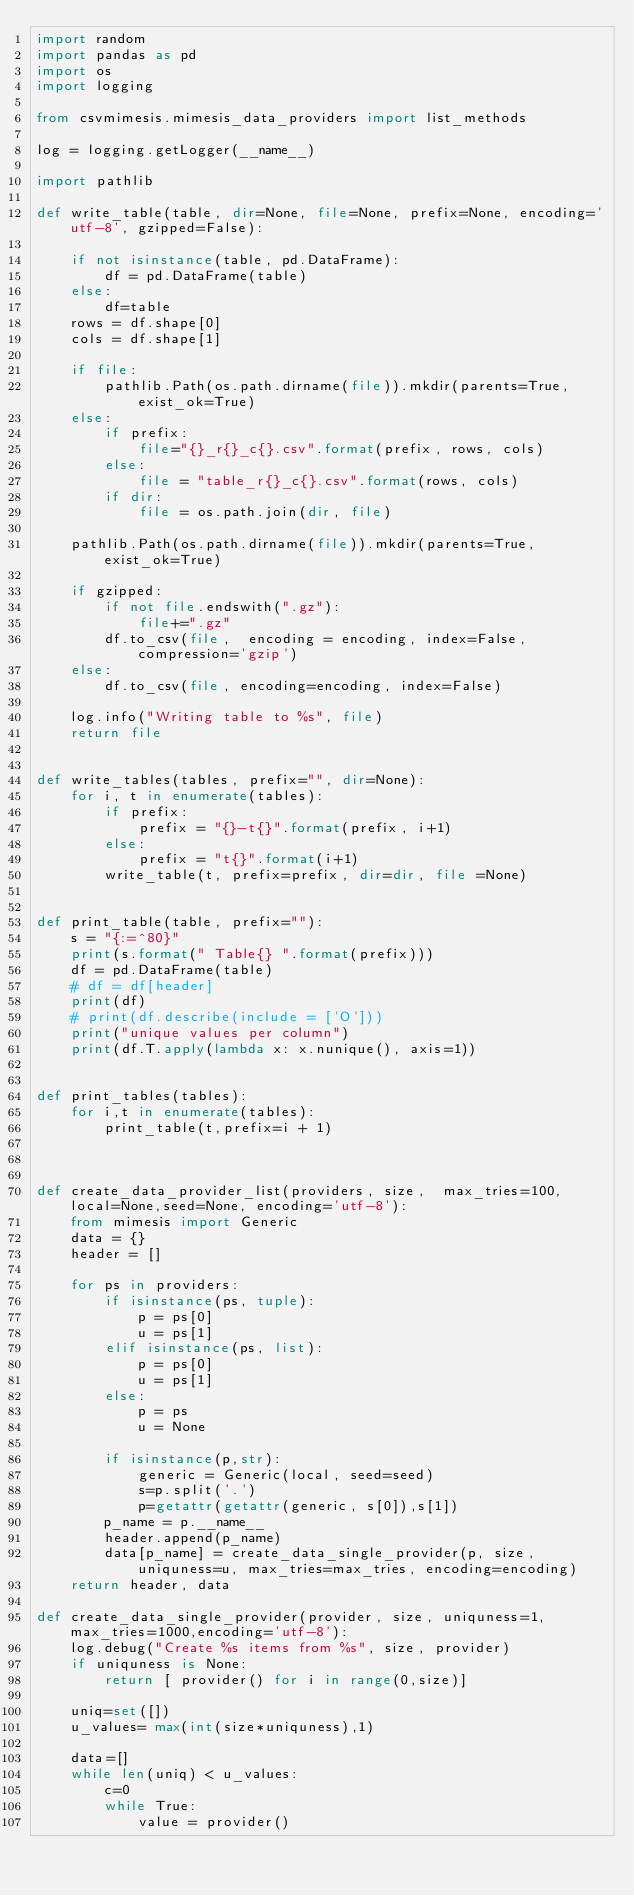Convert code to text. <code><loc_0><loc_0><loc_500><loc_500><_Python_>import random
import pandas as pd
import os
import logging

from csvmimesis.mimesis_data_providers import list_methods

log = logging.getLogger(__name__)

import pathlib

def write_table(table, dir=None, file=None, prefix=None, encoding='utf-8', gzipped=False):

    if not isinstance(table, pd.DataFrame):
        df = pd.DataFrame(table)
    else:
        df=table
    rows = df.shape[0]
    cols = df.shape[1]

    if file:
        pathlib.Path(os.path.dirname(file)).mkdir(parents=True, exist_ok=True)
    else:
        if prefix:
            file="{}_r{}_c{}.csv".format(prefix, rows, cols)
        else:
            file = "table_r{}_c{}.csv".format(rows, cols)
        if dir:
            file = os.path.join(dir, file)

    pathlib.Path(os.path.dirname(file)).mkdir(parents=True, exist_ok=True)

    if gzipped:
        if not file.endswith(".gz"):
            file+=".gz"
        df.to_csv(file,  encoding = encoding, index=False, compression='gzip')
    else:
        df.to_csv(file, encoding=encoding, index=False)

    log.info("Writing table to %s", file)
    return file


def write_tables(tables, prefix="", dir=None):
    for i, t in enumerate(tables):
        if prefix:
            prefix = "{}-t{}".format(prefix, i+1)
        else:
            prefix = "t{}".format(i+1)
        write_table(t, prefix=prefix, dir=dir, file =None)


def print_table(table, prefix=""):
    s = "{:=^80}"
    print(s.format(" Table{} ".format(prefix)))
    df = pd.DataFrame(table)
    # df = df[header]
    print(df)
    # print(df.describe(include = ['O']))
    print("unique values per column")
    print(df.T.apply(lambda x: x.nunique(), axis=1))


def print_tables(tables):
    for i,t in enumerate(tables):
        print_table(t,prefix=i + 1)



def create_data_provider_list(providers, size,  max_tries=100, local=None,seed=None, encoding='utf-8'):
    from mimesis import Generic
    data = {}
    header = []

    for ps in providers:
        if isinstance(ps, tuple):
            p = ps[0]
            u = ps[1]
        elif isinstance(ps, list):
            p = ps[0]
            u = ps[1]
        else:
            p = ps
            u = None

        if isinstance(p,str):
            generic = Generic(local, seed=seed)
            s=p.split('.')
            p=getattr(getattr(generic, s[0]),s[1])
        p_name = p.__name__
        header.append(p_name)
        data[p_name] = create_data_single_provider(p, size, uniquness=u, max_tries=max_tries, encoding=encoding)
    return header, data

def create_data_single_provider(provider, size, uniquness=1, max_tries=1000,encoding='utf-8'):
    log.debug("Create %s items from %s", size, provider)
    if uniquness is None:
        return [ provider() for i in range(0,size)]

    uniq=set([])
    u_values= max(int(size*uniquness),1)

    data=[]
    while len(uniq) < u_values:
        c=0
        while True:
            value = provider()</code> 